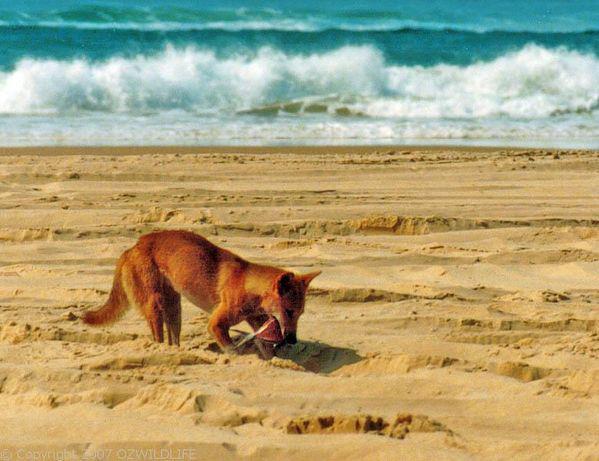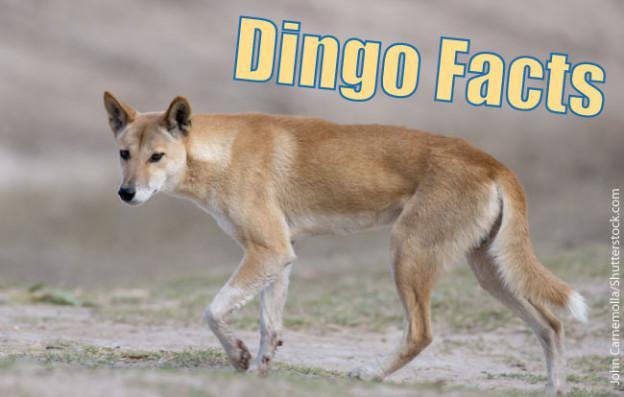The first image is the image on the left, the second image is the image on the right. Assess this claim about the two images: "Each photo shows a single dingo in the wild.". Correct or not? Answer yes or no. Yes. The first image is the image on the left, the second image is the image on the right. Assess this claim about the two images: "There are only two dogs and both are looking in different directions.". Correct or not? Answer yes or no. Yes. 